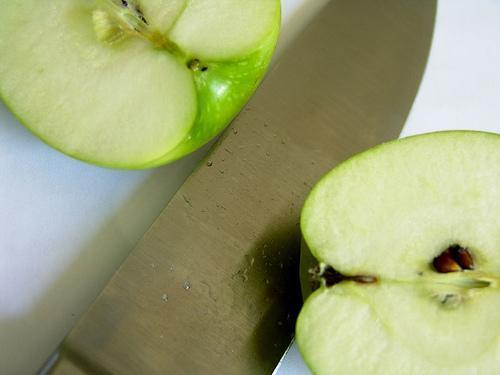How many seeds can you see?
Give a very brief answer. 2. How many apples are there?
Give a very brief answer. 2. How many orange cats are there in the image?
Give a very brief answer. 0. 